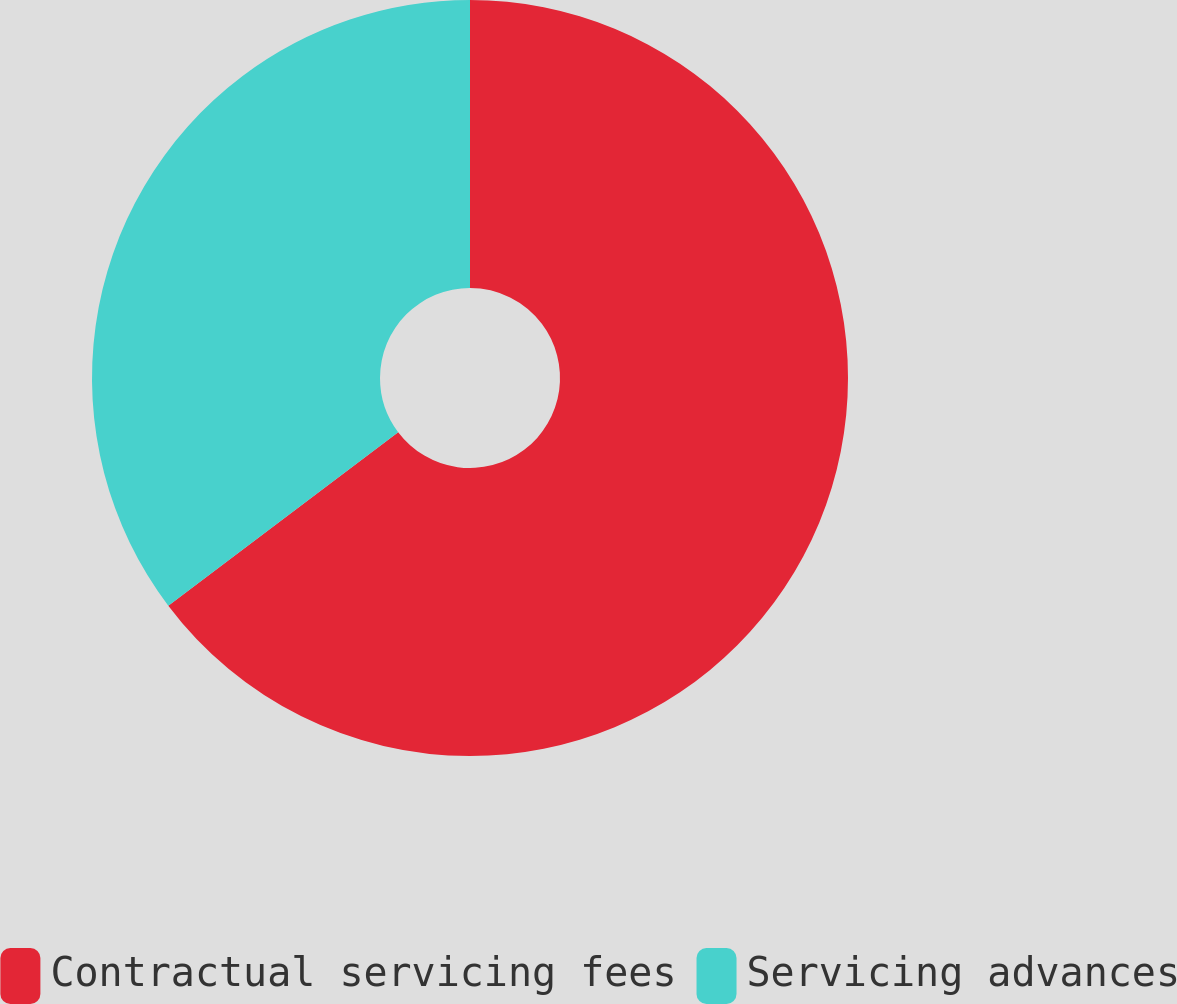<chart> <loc_0><loc_0><loc_500><loc_500><pie_chart><fcel>Contractual servicing fees<fcel>Servicing advances<nl><fcel>64.71%<fcel>35.29%<nl></chart> 